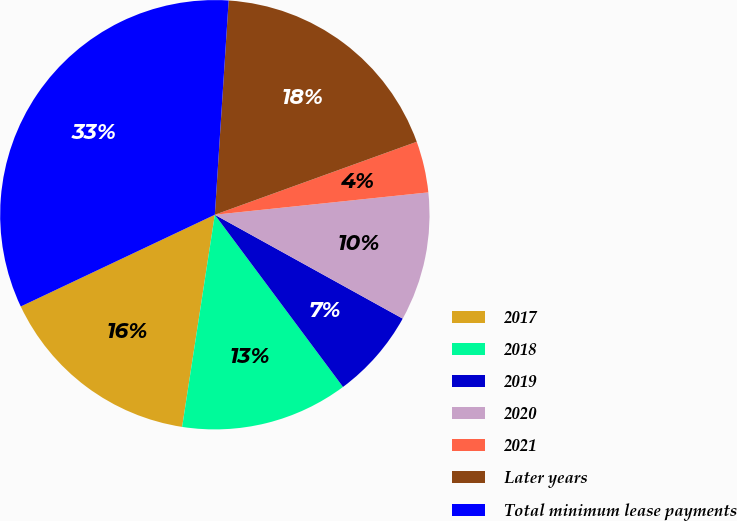Convert chart to OTSL. <chart><loc_0><loc_0><loc_500><loc_500><pie_chart><fcel>2017<fcel>2018<fcel>2019<fcel>2020<fcel>2021<fcel>Later years<fcel>Total minimum lease payments<nl><fcel>15.54%<fcel>12.62%<fcel>6.78%<fcel>9.7%<fcel>3.86%<fcel>18.46%<fcel>33.06%<nl></chart> 